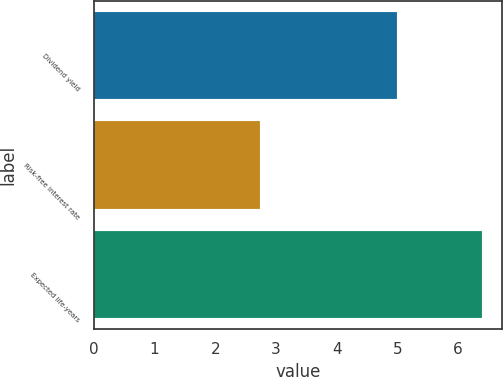Convert chart to OTSL. <chart><loc_0><loc_0><loc_500><loc_500><bar_chart><fcel>Dividend yield<fcel>Risk-free interest rate<fcel>Expected life-years<nl><fcel>5<fcel>2.74<fcel>6.4<nl></chart> 